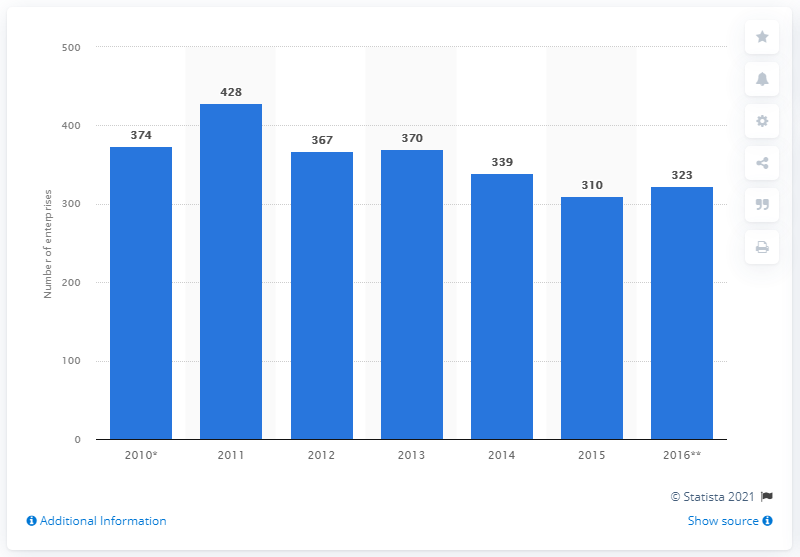Point out several critical features in this image. There were 310 enterprises operating in Slovakia's leather and related products industry in 2015. 